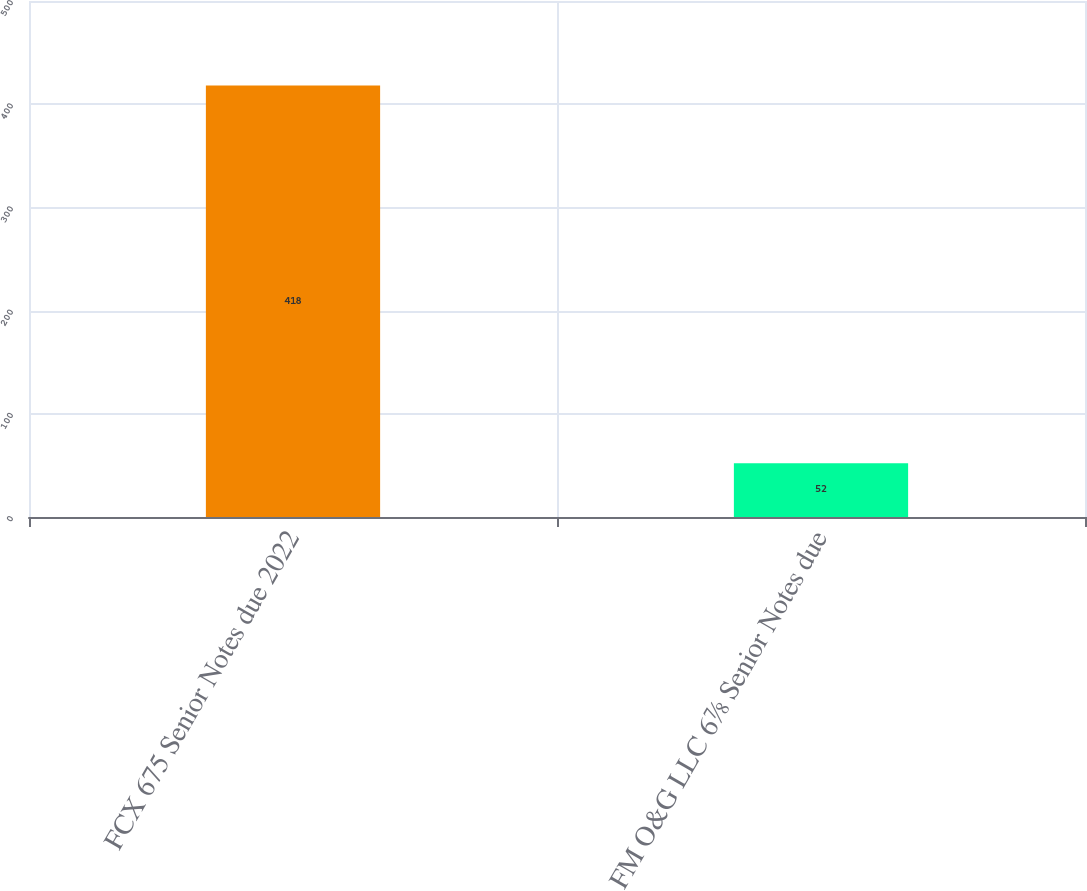Convert chart to OTSL. <chart><loc_0><loc_0><loc_500><loc_500><bar_chart><fcel>FCX 675 Senior Notes due 2022<fcel>FM O&G LLC 6⅞ Senior Notes due<nl><fcel>418<fcel>52<nl></chart> 